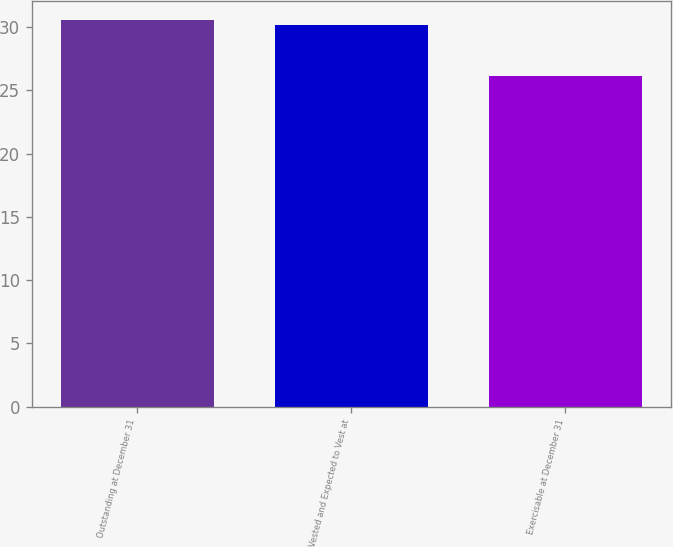Convert chart. <chart><loc_0><loc_0><loc_500><loc_500><bar_chart><fcel>Outstanding at December 31<fcel>Vested and Expected to Vest at<fcel>Exercisable at December 31<nl><fcel>30.56<fcel>30.14<fcel>26.12<nl></chart> 